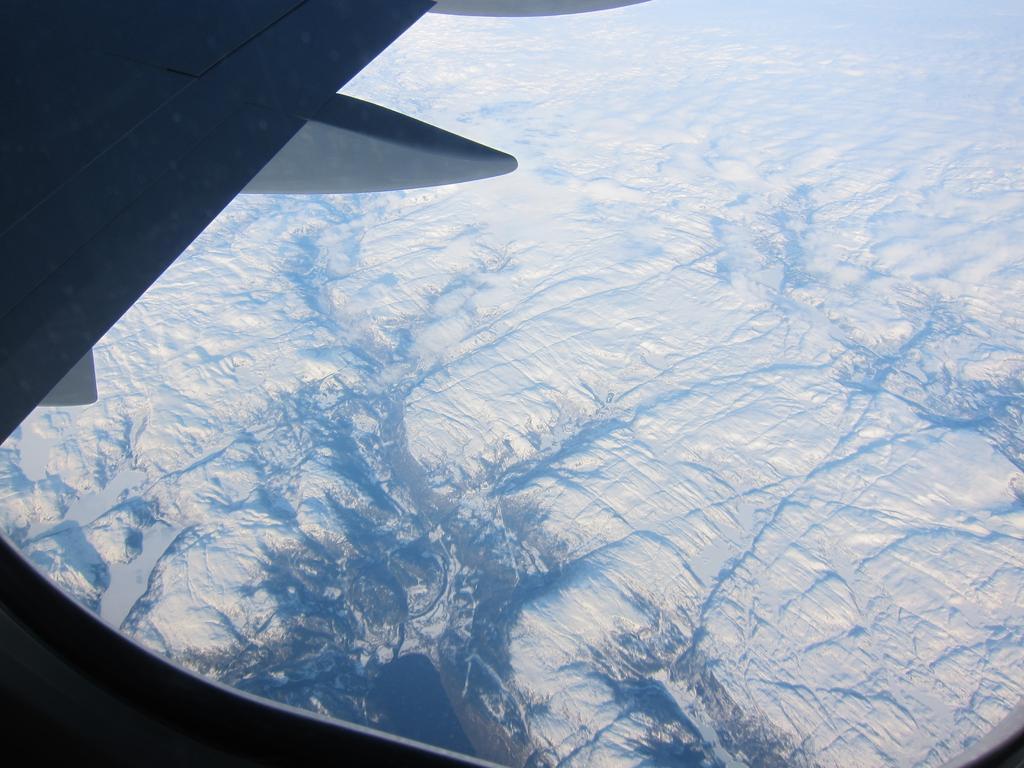Describe this image in one or two sentences. In this image we can see inside of an aircraft. We can see a part of the aircraft in the image. There are many mountains in the image. 